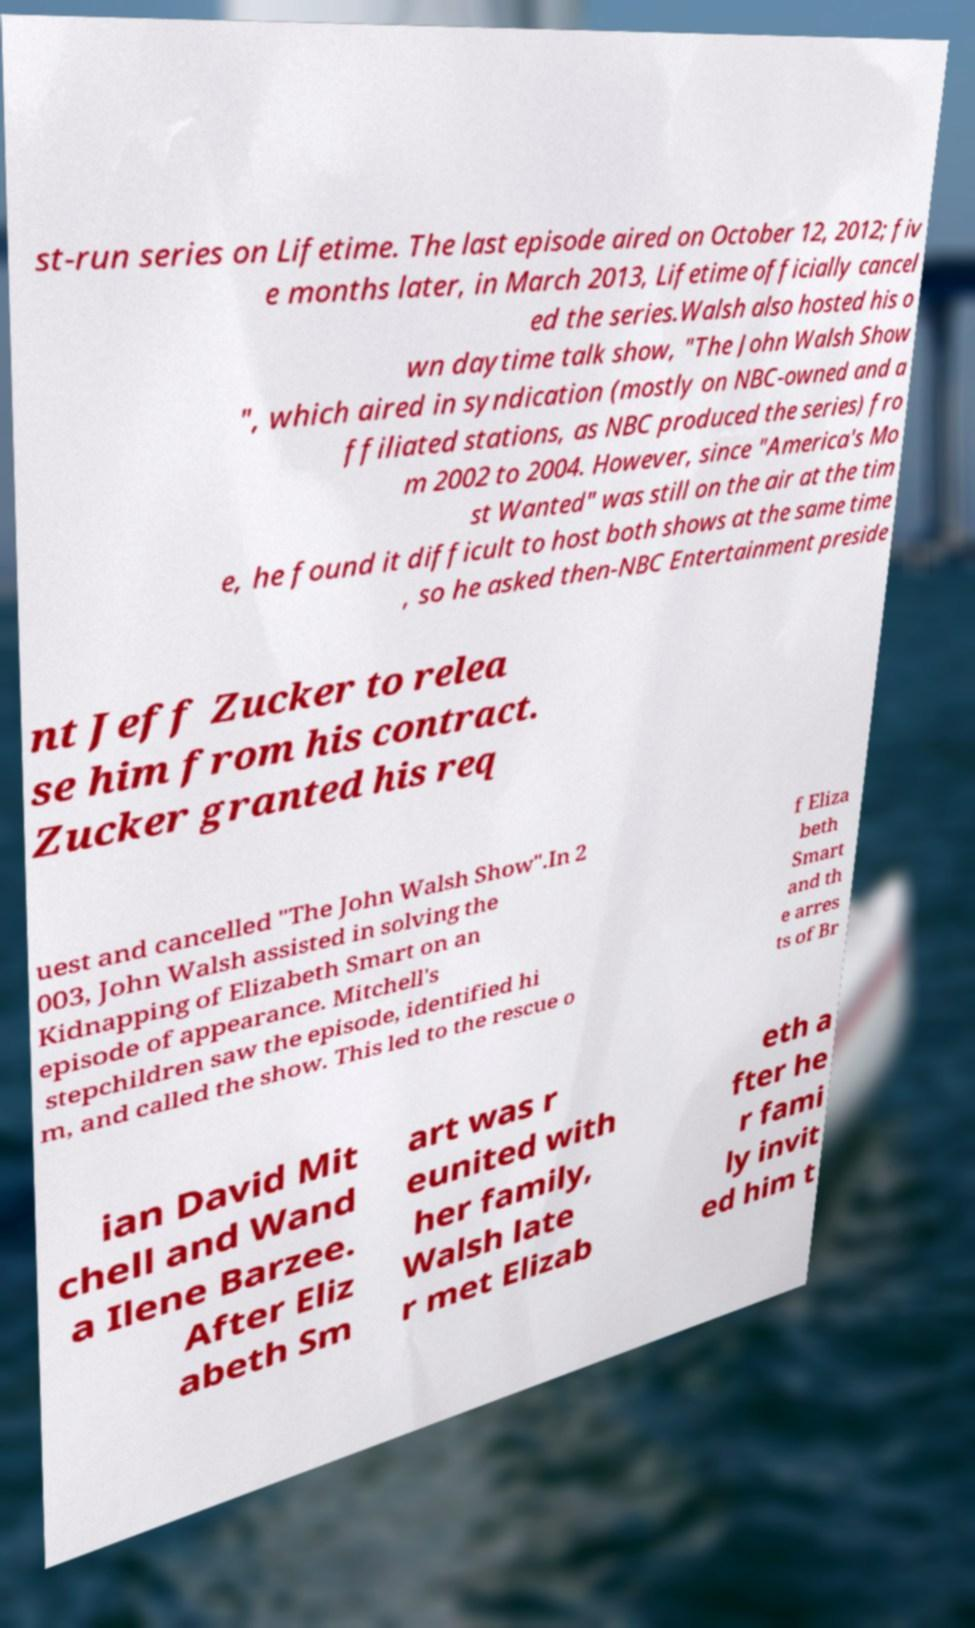For documentation purposes, I need the text within this image transcribed. Could you provide that? st-run series on Lifetime. The last episode aired on October 12, 2012; fiv e months later, in March 2013, Lifetime officially cancel ed the series.Walsh also hosted his o wn daytime talk show, "The John Walsh Show ", which aired in syndication (mostly on NBC-owned and a ffiliated stations, as NBC produced the series) fro m 2002 to 2004. However, since "America's Mo st Wanted" was still on the air at the tim e, he found it difficult to host both shows at the same time , so he asked then-NBC Entertainment preside nt Jeff Zucker to relea se him from his contract. Zucker granted his req uest and cancelled "The John Walsh Show".In 2 003, John Walsh assisted in solving the Kidnapping of Elizabeth Smart on an episode of appearance. Mitchell's stepchildren saw the episode, identified hi m, and called the show. This led to the rescue o f Eliza beth Smart and th e arres ts of Br ian David Mit chell and Wand a Ilene Barzee. After Eliz abeth Sm art was r eunited with her family, Walsh late r met Elizab eth a fter he r fami ly invit ed him t 